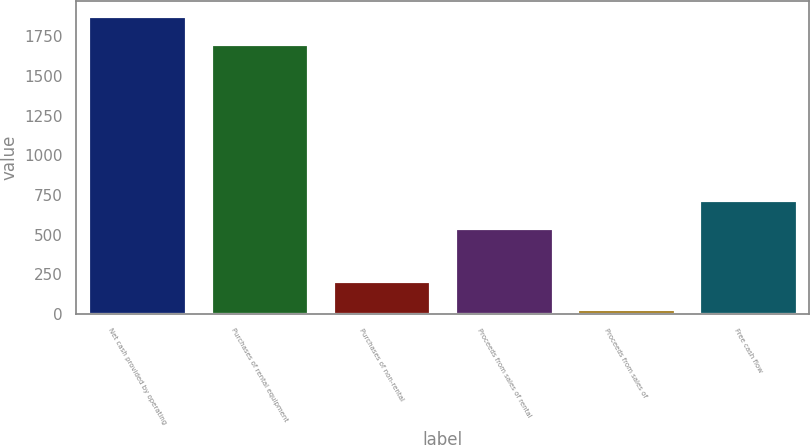<chart> <loc_0><loc_0><loc_500><loc_500><bar_chart><fcel>Net cash provided by operating<fcel>Purchases of rental equipment<fcel>Purchases of non-rental<fcel>Proceeds from sales of rental<fcel>Proceeds from sales of<fcel>Free cash flow<nl><fcel>1877.8<fcel>1701<fcel>209.8<fcel>544<fcel>33<fcel>720.8<nl></chart> 